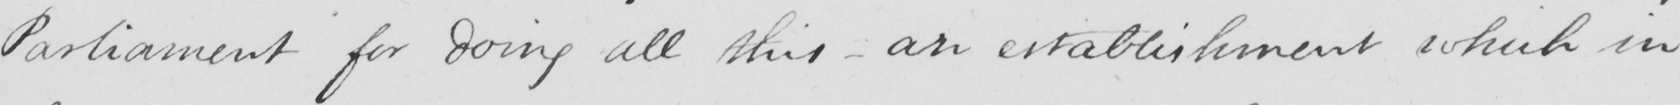Transcribe the text shown in this historical manuscript line. Parliament for doing all this  _  an establishment which in 